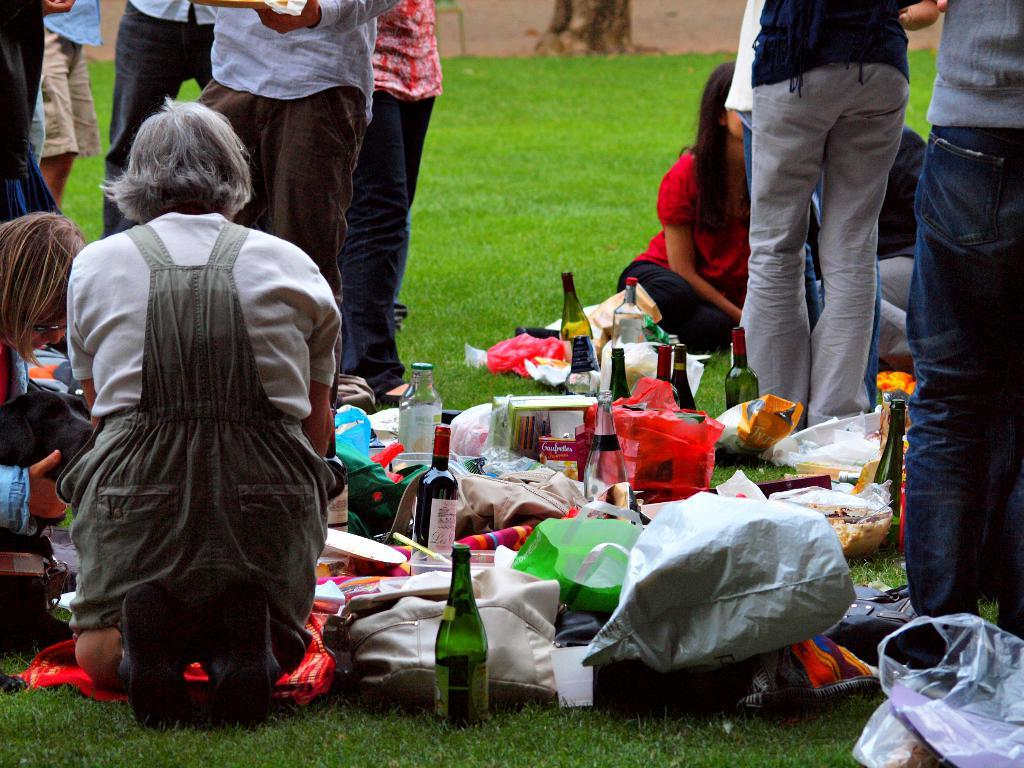What are the people in the image doing? The people in the image are sitting on the grass. What else can be seen on the ground in the image? Food eatables are present on the floor in the image. Can you describe the people in the background of the image? There are people standing in the background of the image. What type of straw is being used to extinguish the fire in the image? There is no fire present in the image, so there is no need for straw to extinguish it. Can you describe the kitty playing with the people in the image? There is no kitty present in the image; the people are sitting on the grass and there are no animals mentioned. 